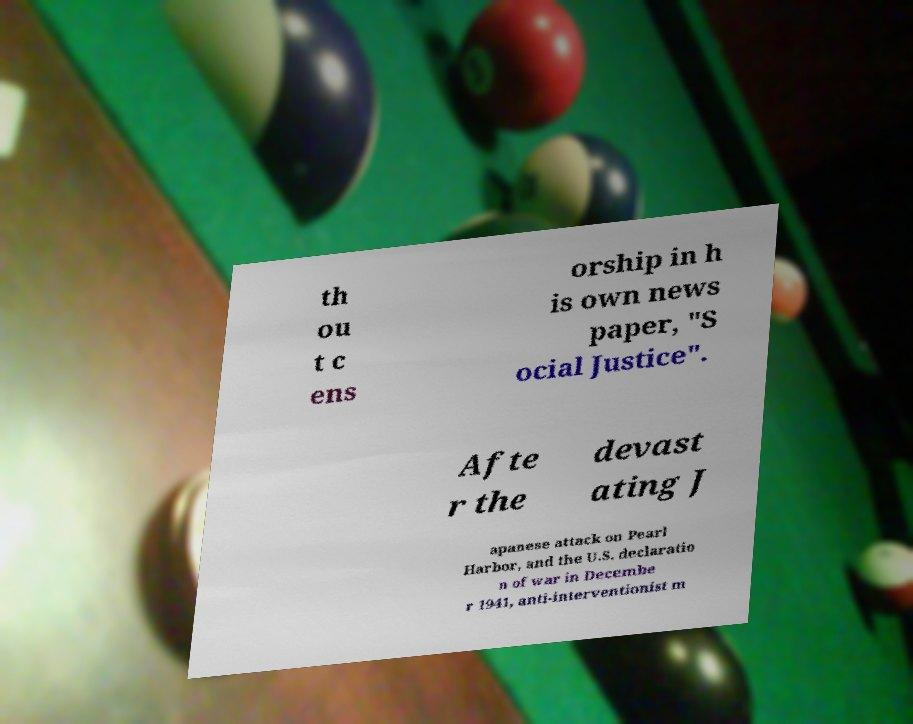Please read and relay the text visible in this image. What does it say? th ou t c ens orship in h is own news paper, "S ocial Justice". Afte r the devast ating J apanese attack on Pearl Harbor, and the U.S. declaratio n of war in Decembe r 1941, anti-interventionist m 